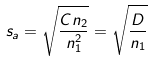Convert formula to latex. <formula><loc_0><loc_0><loc_500><loc_500>s _ { a } = \sqrt { \frac { C n _ { 2 } } { n _ { 1 } ^ { 2 } } } = \sqrt { \frac { D } { n _ { 1 } } }</formula> 